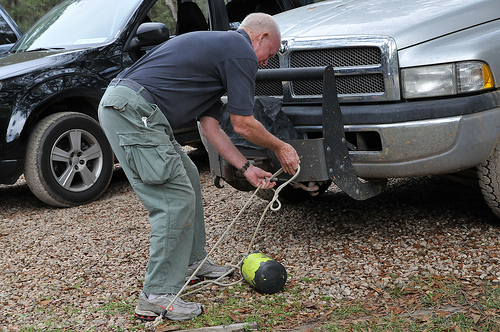Is he wearing shorts? No, he is not wearing shorts. The man is dressed in gray trousers, suitable for outdoor activities. 